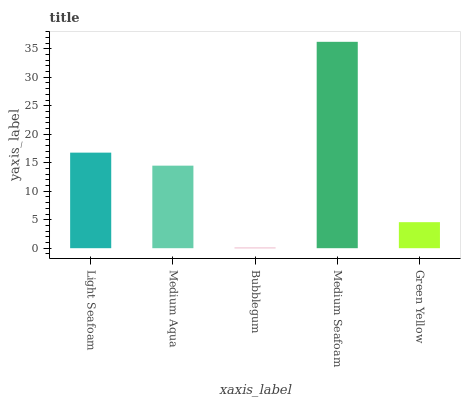Is Medium Aqua the minimum?
Answer yes or no. No. Is Medium Aqua the maximum?
Answer yes or no. No. Is Light Seafoam greater than Medium Aqua?
Answer yes or no. Yes. Is Medium Aqua less than Light Seafoam?
Answer yes or no. Yes. Is Medium Aqua greater than Light Seafoam?
Answer yes or no. No. Is Light Seafoam less than Medium Aqua?
Answer yes or no. No. Is Medium Aqua the high median?
Answer yes or no. Yes. Is Medium Aqua the low median?
Answer yes or no. Yes. Is Green Yellow the high median?
Answer yes or no. No. Is Bubblegum the low median?
Answer yes or no. No. 